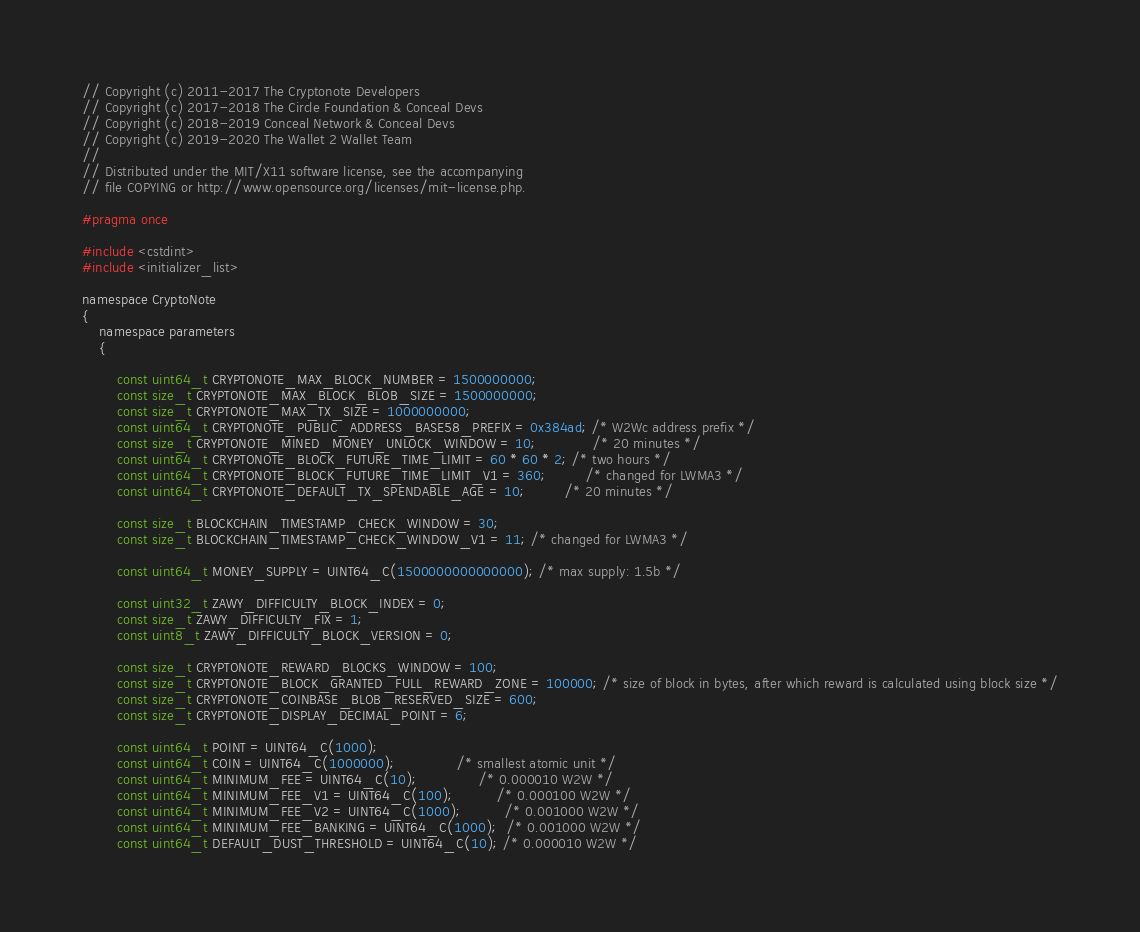<code> <loc_0><loc_0><loc_500><loc_500><_C_>// Copyright (c) 2011-2017 The Cryptonote Developers
// Copyright (c) 2017-2018 The Circle Foundation & Conceal Devs
// Copyright (c) 2018-2019 Conceal Network & Conceal Devs
// Copyright (c) 2019-2020 The Wallet 2 Wallet Team
//
// Distributed under the MIT/X11 software license, see the accompanying
// file COPYING or http://www.opensource.org/licenses/mit-license.php.

#pragma once

#include <cstdint>
#include <initializer_list>

namespace CryptoNote
{
	namespace parameters
	{

		const uint64_t CRYPTONOTE_MAX_BLOCK_NUMBER = 1500000000;
		const size_t CRYPTONOTE_MAX_BLOCK_BLOB_SIZE = 1500000000;
		const size_t CRYPTONOTE_MAX_TX_SIZE = 1000000000;
		const uint64_t CRYPTONOTE_PUBLIC_ADDRESS_BASE58_PREFIX = 0x384ad; /* W2Wc address prefix */
		const size_t CRYPTONOTE_MINED_MONEY_UNLOCK_WINDOW = 10;			 /* 20 minutes */
		const uint64_t CRYPTONOTE_BLOCK_FUTURE_TIME_LIMIT = 60 * 60 * 2; /* two hours */
		const uint64_t CRYPTONOTE_BLOCK_FUTURE_TIME_LIMIT_V1 = 360;		 /* changed for LWMA3 */
		const uint64_t CRYPTONOTE_DEFAULT_TX_SPENDABLE_AGE = 10;		 /* 20 minutes */

		const size_t BLOCKCHAIN_TIMESTAMP_CHECK_WINDOW = 30;
		const size_t BLOCKCHAIN_TIMESTAMP_CHECK_WINDOW_V1 = 11; /* changed for LWMA3 */

		const uint64_t MONEY_SUPPLY = UINT64_C(1500000000000000); /* max supply: 1.5b */

		const uint32_t ZAWY_DIFFICULTY_BLOCK_INDEX = 0;
		const size_t ZAWY_DIFFICULTY_FIX = 1;
		const uint8_t ZAWY_DIFFICULTY_BLOCK_VERSION = 0;

		const size_t CRYPTONOTE_REWARD_BLOCKS_WINDOW = 100;
		const size_t CRYPTONOTE_BLOCK_GRANTED_FULL_REWARD_ZONE = 100000; /* size of block in bytes, after which reward is calculated using block size */
		const size_t CRYPTONOTE_COINBASE_BLOB_RESERVED_SIZE = 600;
		const size_t CRYPTONOTE_DISPLAY_DECIMAL_POINT = 6;

		const uint64_t POINT = UINT64_C(1000);
		const uint64_t COIN = UINT64_C(1000000);			  /* smallest atomic unit */
		const uint64_t MINIMUM_FEE = UINT64_C(10);			  /* 0.000010 W2W */
		const uint64_t MINIMUM_FEE_V1 = UINT64_C(100);		  /* 0.000100 W2W */
		const uint64_t MINIMUM_FEE_V2 = UINT64_C(1000);		  /* 0.001000 W2W */
		const uint64_t MINIMUM_FEE_BANKING = UINT64_C(1000);  /* 0.001000 W2W */
		const uint64_t DEFAULT_DUST_THRESHOLD = UINT64_C(10); /* 0.000010 W2W */
</code> 